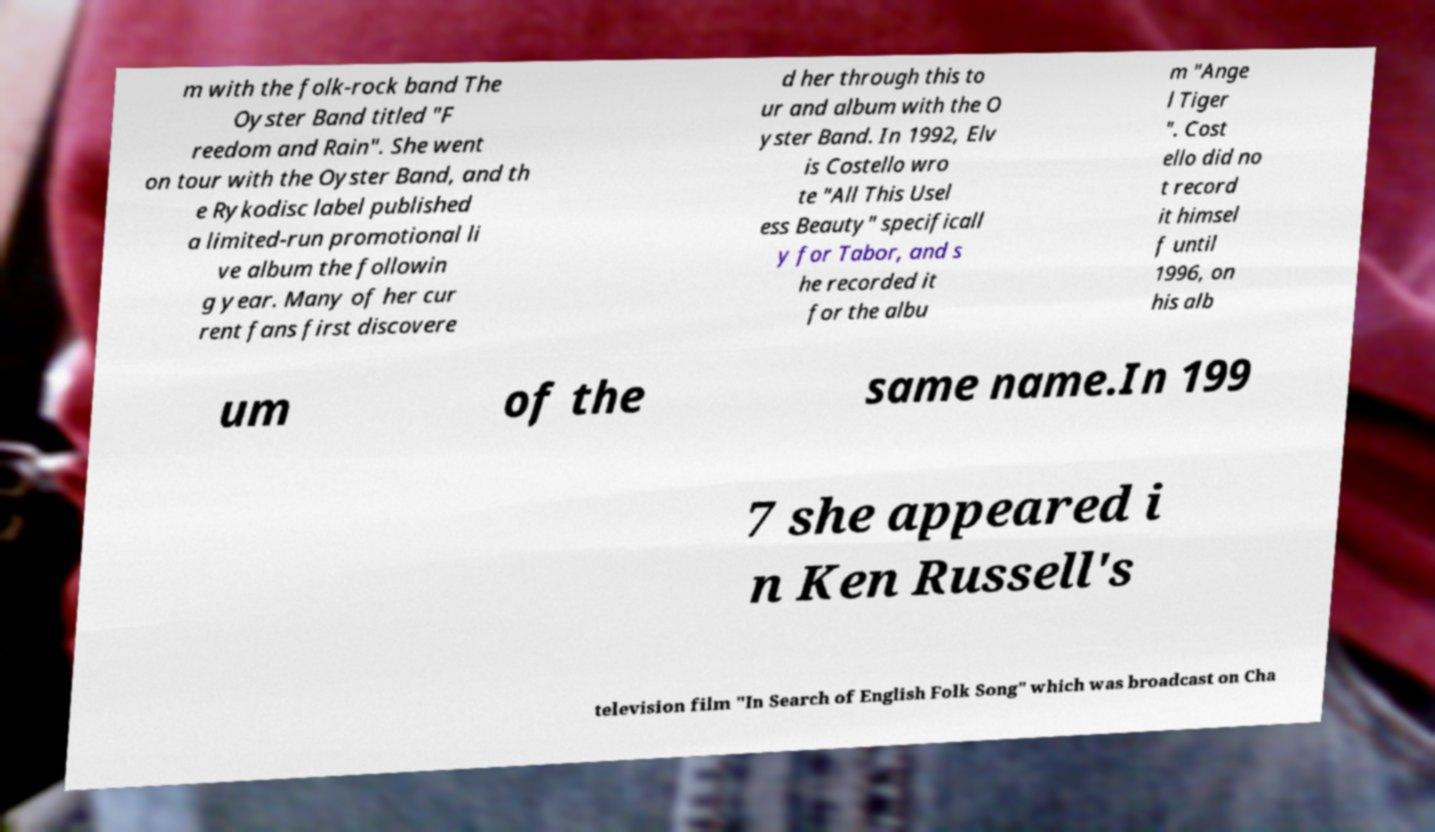Can you accurately transcribe the text from the provided image for me? m with the folk-rock band The Oyster Band titled "F reedom and Rain". She went on tour with the Oyster Band, and th e Rykodisc label published a limited-run promotional li ve album the followin g year. Many of her cur rent fans first discovere d her through this to ur and album with the O yster Band. In 1992, Elv is Costello wro te "All This Usel ess Beauty" specificall y for Tabor, and s he recorded it for the albu m "Ange l Tiger ". Cost ello did no t record it himsel f until 1996, on his alb um of the same name.In 199 7 she appeared i n Ken Russell's television film "In Search of English Folk Song" which was broadcast on Cha 